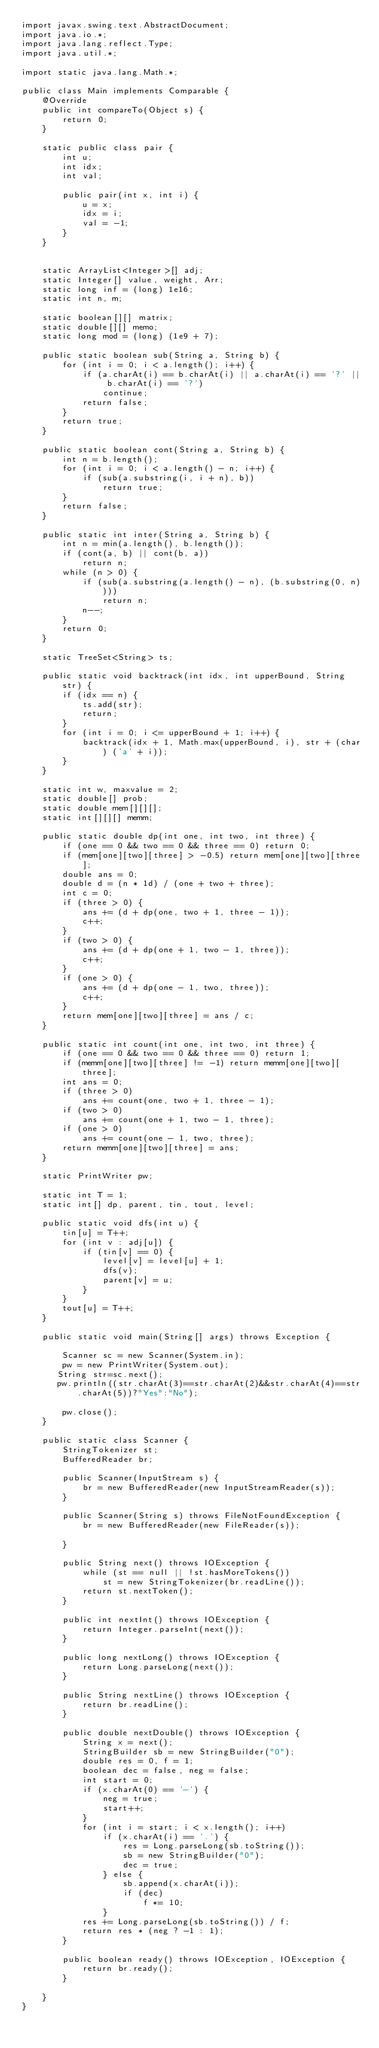Convert code to text. <code><loc_0><loc_0><loc_500><loc_500><_Java_>import javax.swing.text.AbstractDocument;
import java.io.*;
import java.lang.reflect.Type;
import java.util.*;

import static java.lang.Math.*;

public class Main implements Comparable {
    @Override
    public int compareTo(Object s) {
        return 0;
    }

    static public class pair {
        int u;
        int idx;
        int val;

        public pair(int x, int i) {
            u = x;
            idx = i;
            val = -1;
        }
    }


    static ArrayList<Integer>[] adj;
    static Integer[] value, weight, Arr;
    static long inf = (long) 1e16;
    static int n, m;

    static boolean[][] matrix;
    static double[][] memo;
    static long mod = (long) (1e9 + 7);

    public static boolean sub(String a, String b) {
        for (int i = 0; i < a.length(); i++) {
            if (a.charAt(i) == b.charAt(i) || a.charAt(i) == '?' || b.charAt(i) == '?')
                continue;
            return false;
        }
        return true;
    }

    public static boolean cont(String a, String b) {
        int n = b.length();
        for (int i = 0; i < a.length() - n; i++) {
            if (sub(a.substring(i, i + n), b))
                return true;
        }
        return false;
    }

    public static int inter(String a, String b) {
        int n = min(a.length(), b.length());
        if (cont(a, b) || cont(b, a))
            return n;
        while (n > 0) {
            if (sub(a.substring(a.length() - n), (b.substring(0, n))))
                return n;
            n--;
        }
        return 0;
    }

    static TreeSet<String> ts;

    public static void backtrack(int idx, int upperBound, String str) {
        if (idx == n) {
            ts.add(str);
            return;
        }
        for (int i = 0; i <= upperBound + 1; i++) {
            backtrack(idx + 1, Math.max(upperBound, i), str + (char) ('a' + i));
        }
    }

    static int w, maxvalue = 2;
    static double[] prob;
    static double mem[][][];
    static int[][][] memm;

    public static double dp(int one, int two, int three) {
        if (one == 0 && two == 0 && three == 0) return 0;
        if (mem[one][two][three] > -0.5) return mem[one][two][three];
        double ans = 0;
        double d = (n * 1d) / (one + two + three);
        int c = 0;
        if (three > 0) {
            ans += (d + dp(one, two + 1, three - 1));
            c++;
        }
        if (two > 0) {
            ans += (d + dp(one + 1, two - 1, three));
            c++;
        }
        if (one > 0) {
            ans += (d + dp(one - 1, two, three));
            c++;
        }
        return mem[one][two][three] = ans / c;
    }

    public static int count(int one, int two, int three) {
        if (one == 0 && two == 0 && three == 0) return 1;
        if (memm[one][two][three] != -1) return memm[one][two][three];
        int ans = 0;
        if (three > 0)
            ans += count(one, two + 1, three - 1);
        if (two > 0)
            ans += count(one + 1, two - 1, three);
        if (one > 0)
            ans += count(one - 1, two, three);
        return memm[one][two][three] = ans;
    }

    static PrintWriter pw;

    static int T = 1;
    static int[] dp, parent, tin, tout, level;

    public static void dfs(int u) {
        tin[u] = T++;
        for (int v : adj[u]) {
            if (tin[v] == 0) {
                level[v] = level[u] + 1;
                dfs(v);
                parent[v] = u;
            }
        }
        tout[u] = T++;
    }

    public static void main(String[] args) throws Exception {

        Scanner sc = new Scanner(System.in);
        pw = new PrintWriter(System.out);
       String str=sc.next();
       pw.println((str.charAt(3)==str.charAt(2)&&str.charAt(4)==str.charAt(5))?"Yes":"No");

        pw.close();
    }

    public static class Scanner {
        StringTokenizer st;
        BufferedReader br;

        public Scanner(InputStream s) {
            br = new BufferedReader(new InputStreamReader(s));
        }

        public Scanner(String s) throws FileNotFoundException {
            br = new BufferedReader(new FileReader(s));

        }

        public String next() throws IOException {
            while (st == null || !st.hasMoreTokens())
                st = new StringTokenizer(br.readLine());
            return st.nextToken();
        }

        public int nextInt() throws IOException {
            return Integer.parseInt(next());
        }

        public long nextLong() throws IOException {
            return Long.parseLong(next());
        }

        public String nextLine() throws IOException {
            return br.readLine();
        }

        public double nextDouble() throws IOException {
            String x = next();
            StringBuilder sb = new StringBuilder("0");
            double res = 0, f = 1;
            boolean dec = false, neg = false;
            int start = 0;
            if (x.charAt(0) == '-') {
                neg = true;
                start++;
            }
            for (int i = start; i < x.length(); i++)
                if (x.charAt(i) == '.') {
                    res = Long.parseLong(sb.toString());
                    sb = new StringBuilder("0");
                    dec = true;
                } else {
                    sb.append(x.charAt(i));
                    if (dec)
                        f *= 10;
                }
            res += Long.parseLong(sb.toString()) / f;
            return res * (neg ? -1 : 1);
        }

        public boolean ready() throws IOException, IOException {
            return br.ready();
        }

    }
}
</code> 